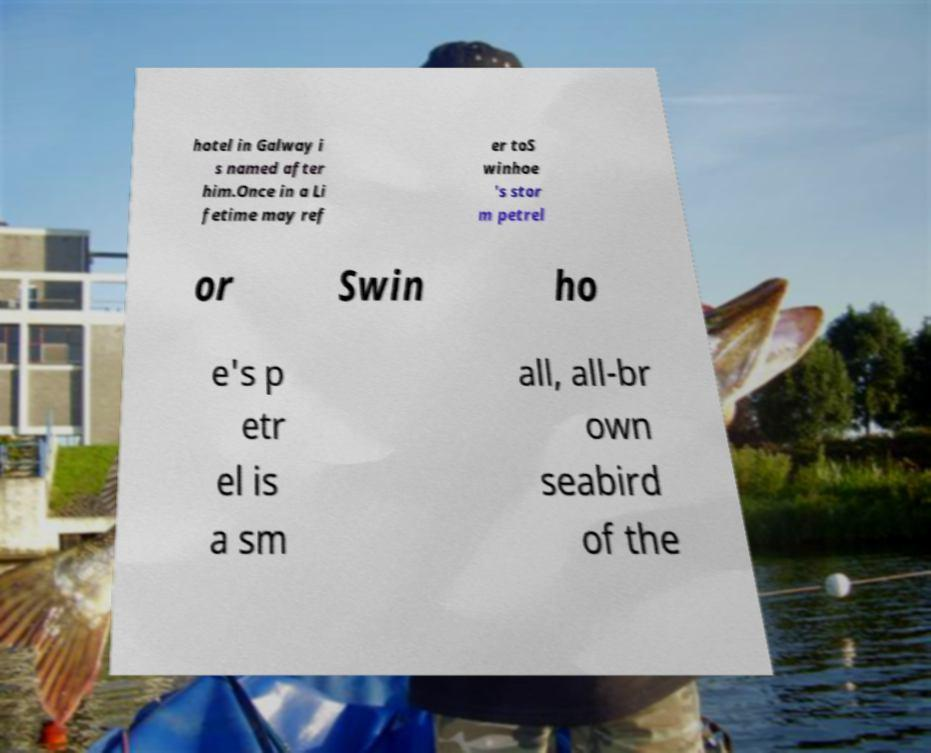Can you read and provide the text displayed in the image?This photo seems to have some interesting text. Can you extract and type it out for me? hotel in Galway i s named after him.Once in a Li fetime may ref er toS winhoe 's stor m petrel or Swin ho e's p etr el is a sm all, all-br own seabird of the 